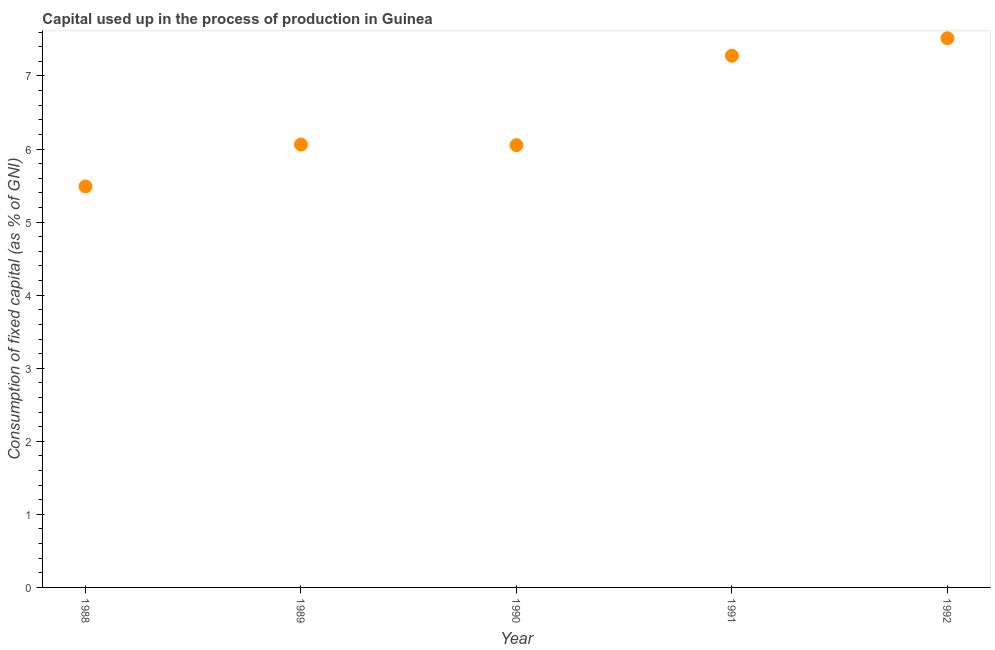What is the consumption of fixed capital in 1992?
Offer a very short reply. 7.52. Across all years, what is the maximum consumption of fixed capital?
Your answer should be very brief. 7.52. Across all years, what is the minimum consumption of fixed capital?
Give a very brief answer. 5.49. In which year was the consumption of fixed capital minimum?
Make the answer very short. 1988. What is the sum of the consumption of fixed capital?
Provide a short and direct response. 32.4. What is the difference between the consumption of fixed capital in 1988 and 1990?
Your answer should be compact. -0.57. What is the average consumption of fixed capital per year?
Offer a very short reply. 6.48. What is the median consumption of fixed capital?
Provide a succinct answer. 6.06. What is the ratio of the consumption of fixed capital in 1990 to that in 1991?
Provide a short and direct response. 0.83. Is the consumption of fixed capital in 1990 less than that in 1992?
Make the answer very short. Yes. What is the difference between the highest and the second highest consumption of fixed capital?
Provide a short and direct response. 0.24. What is the difference between the highest and the lowest consumption of fixed capital?
Keep it short and to the point. 2.03. In how many years, is the consumption of fixed capital greater than the average consumption of fixed capital taken over all years?
Offer a very short reply. 2. How many dotlines are there?
Provide a short and direct response. 1. What is the difference between two consecutive major ticks on the Y-axis?
Offer a very short reply. 1. Are the values on the major ticks of Y-axis written in scientific E-notation?
Your response must be concise. No. Does the graph contain grids?
Provide a short and direct response. No. What is the title of the graph?
Keep it short and to the point. Capital used up in the process of production in Guinea. What is the label or title of the X-axis?
Offer a very short reply. Year. What is the label or title of the Y-axis?
Provide a succinct answer. Consumption of fixed capital (as % of GNI). What is the Consumption of fixed capital (as % of GNI) in 1988?
Your response must be concise. 5.49. What is the Consumption of fixed capital (as % of GNI) in 1989?
Ensure brevity in your answer.  6.06. What is the Consumption of fixed capital (as % of GNI) in 1990?
Offer a terse response. 6.05. What is the Consumption of fixed capital (as % of GNI) in 1991?
Your answer should be very brief. 7.28. What is the Consumption of fixed capital (as % of GNI) in 1992?
Give a very brief answer. 7.52. What is the difference between the Consumption of fixed capital (as % of GNI) in 1988 and 1989?
Make the answer very short. -0.57. What is the difference between the Consumption of fixed capital (as % of GNI) in 1988 and 1990?
Provide a short and direct response. -0.57. What is the difference between the Consumption of fixed capital (as % of GNI) in 1988 and 1991?
Your response must be concise. -1.79. What is the difference between the Consumption of fixed capital (as % of GNI) in 1988 and 1992?
Keep it short and to the point. -2.03. What is the difference between the Consumption of fixed capital (as % of GNI) in 1989 and 1990?
Make the answer very short. 0.01. What is the difference between the Consumption of fixed capital (as % of GNI) in 1989 and 1991?
Your answer should be very brief. -1.22. What is the difference between the Consumption of fixed capital (as % of GNI) in 1989 and 1992?
Your answer should be very brief. -1.45. What is the difference between the Consumption of fixed capital (as % of GNI) in 1990 and 1991?
Your answer should be very brief. -1.22. What is the difference between the Consumption of fixed capital (as % of GNI) in 1990 and 1992?
Provide a short and direct response. -1.46. What is the difference between the Consumption of fixed capital (as % of GNI) in 1991 and 1992?
Your answer should be compact. -0.24. What is the ratio of the Consumption of fixed capital (as % of GNI) in 1988 to that in 1989?
Your answer should be compact. 0.91. What is the ratio of the Consumption of fixed capital (as % of GNI) in 1988 to that in 1990?
Make the answer very short. 0.91. What is the ratio of the Consumption of fixed capital (as % of GNI) in 1988 to that in 1991?
Offer a terse response. 0.75. What is the ratio of the Consumption of fixed capital (as % of GNI) in 1988 to that in 1992?
Keep it short and to the point. 0.73. What is the ratio of the Consumption of fixed capital (as % of GNI) in 1989 to that in 1991?
Your response must be concise. 0.83. What is the ratio of the Consumption of fixed capital (as % of GNI) in 1989 to that in 1992?
Make the answer very short. 0.81. What is the ratio of the Consumption of fixed capital (as % of GNI) in 1990 to that in 1991?
Offer a very short reply. 0.83. What is the ratio of the Consumption of fixed capital (as % of GNI) in 1990 to that in 1992?
Make the answer very short. 0.81. 